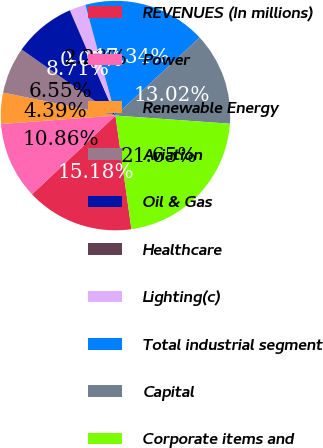Convert chart. <chart><loc_0><loc_0><loc_500><loc_500><pie_chart><fcel>REVENUES (In millions)<fcel>Power<fcel>Renewable Energy<fcel>Aviation<fcel>Oil & Gas<fcel>Healthcare<fcel>Lighting(c)<fcel>Total industrial segment<fcel>Capital<fcel>Corporate items and<nl><fcel>15.18%<fcel>10.86%<fcel>4.39%<fcel>6.55%<fcel>8.71%<fcel>0.07%<fcel>2.23%<fcel>17.34%<fcel>13.02%<fcel>21.65%<nl></chart> 